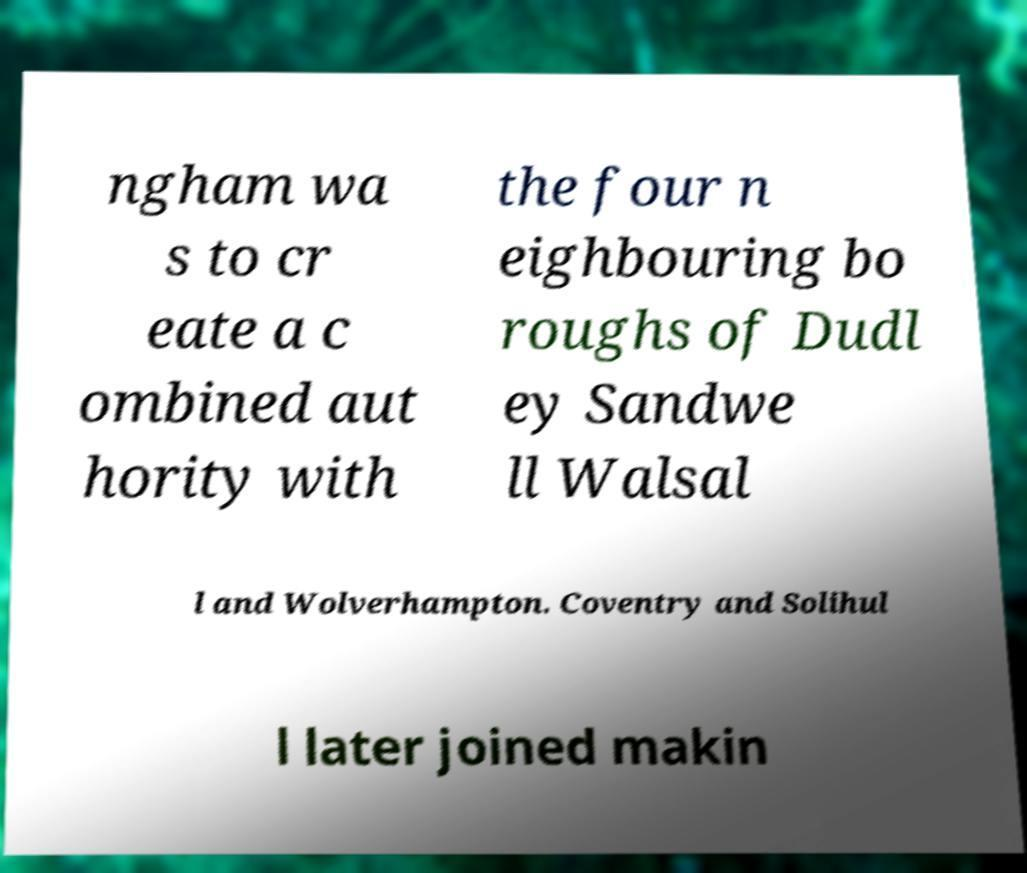Could you assist in decoding the text presented in this image and type it out clearly? ngham wa s to cr eate a c ombined aut hority with the four n eighbouring bo roughs of Dudl ey Sandwe ll Walsal l and Wolverhampton. Coventry and Solihul l later joined makin 